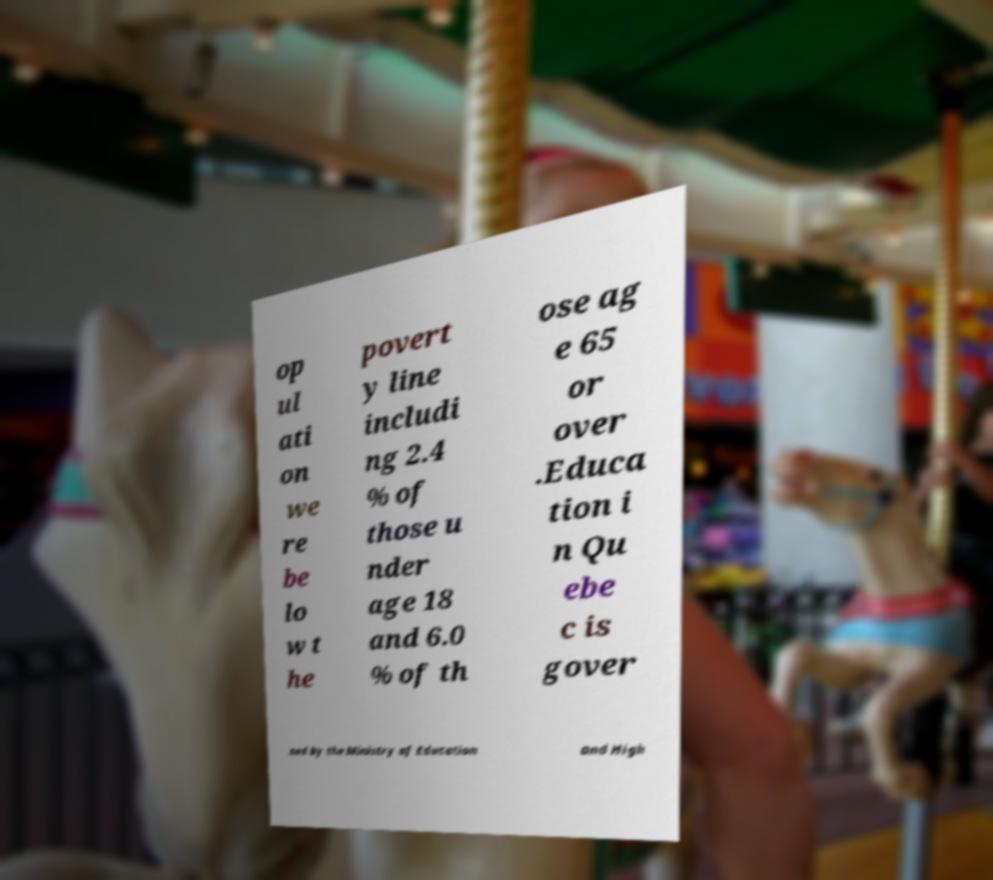Please identify and transcribe the text found in this image. op ul ati on we re be lo w t he povert y line includi ng 2.4 % of those u nder age 18 and 6.0 % of th ose ag e 65 or over .Educa tion i n Qu ebe c is gover ned by the Ministry of Education and High 